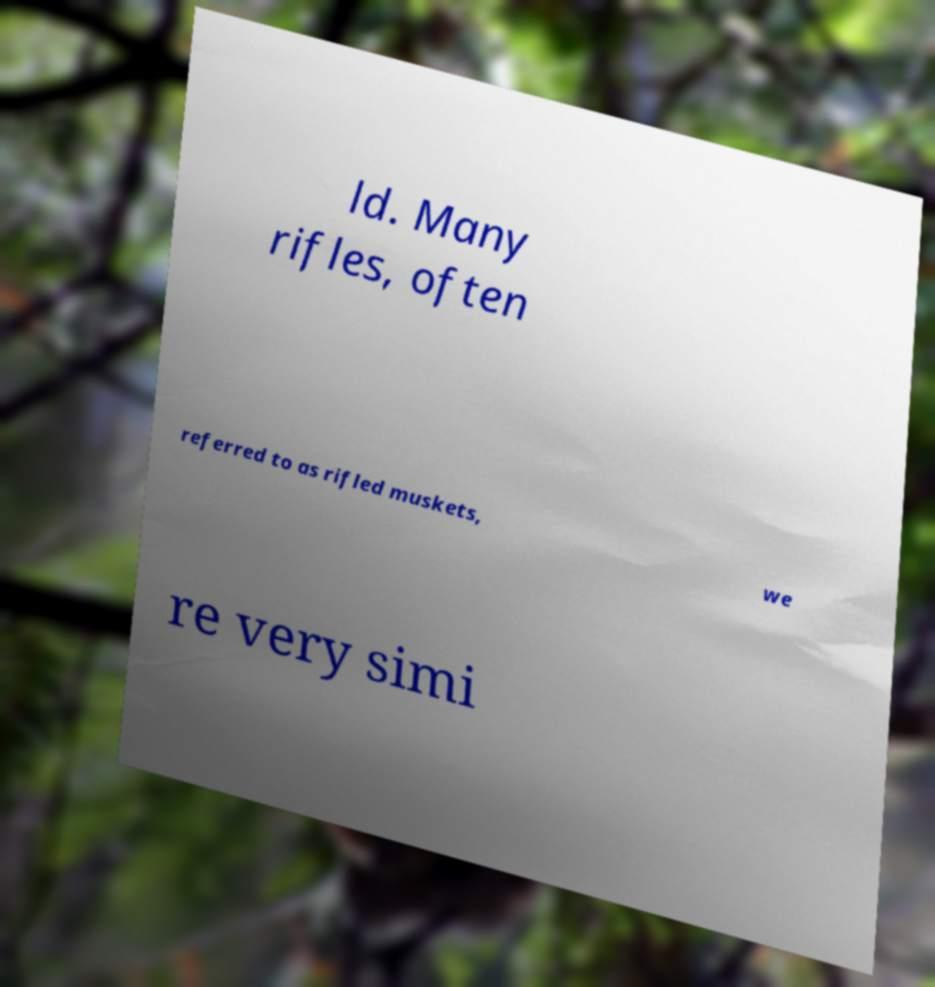Can you read and provide the text displayed in the image?This photo seems to have some interesting text. Can you extract and type it out for me? ld. Many rifles, often referred to as rifled muskets, we re very simi 